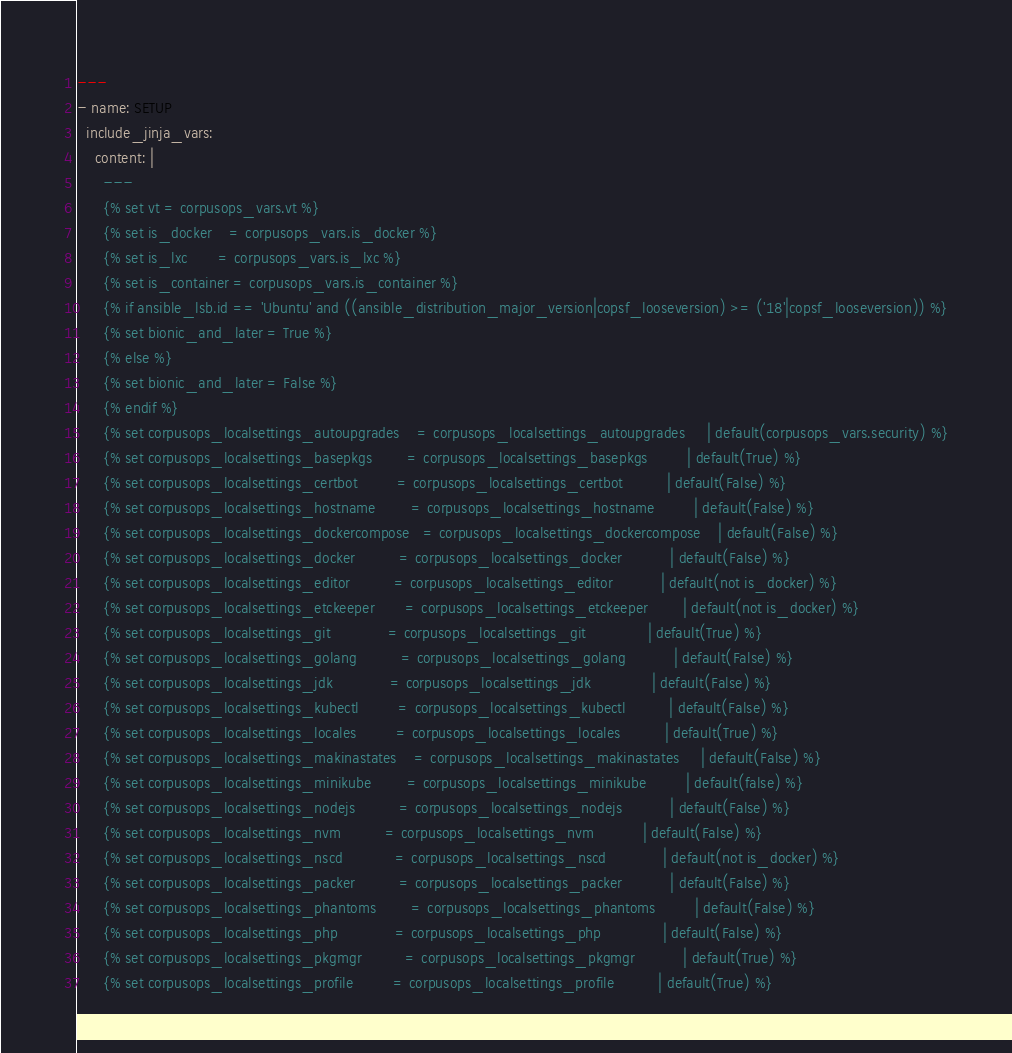Convert code to text. <code><loc_0><loc_0><loc_500><loc_500><_YAML_>---
- name: SETUP
  include_jinja_vars:
    content: |
      ---
      {% set vt = corpusops_vars.vt %}
      {% set is_docker    = corpusops_vars.is_docker %}
      {% set is_lxc       = corpusops_vars.is_lxc %}
      {% set is_container = corpusops_vars.is_container %}
      {% if ansible_lsb.id == 'Ubuntu' and ((ansible_distribution_major_version|copsf_looseversion) >= ('18'|copsf_looseversion)) %}
      {% set bionic_and_later = True %}
      {% else %}
      {% set bionic_and_later = False %}
      {% endif %}
      {% set corpusops_localsettings_autoupgrades    = corpusops_localsettings_autoupgrades     | default(corpusops_vars.security) %}
      {% set corpusops_localsettings_basepkgs        = corpusops_localsettings_basepkgs         | default(True) %}
      {% set corpusops_localsettings_certbot         = corpusops_localsettings_certbot          | default(False) %}
      {% set corpusops_localsettings_hostname        = corpusops_localsettings_hostname         | default(False) %}
      {% set corpusops_localsettings_dockercompose   = corpusops_localsettings_dockercompose    | default(False) %}
      {% set corpusops_localsettings_docker          = corpusops_localsettings_docker           | default(False) %}
      {% set corpusops_localsettings_editor          = corpusops_localsettings_editor           | default(not is_docker) %}
      {% set corpusops_localsettings_etckeeper       = corpusops_localsettings_etckeeper        | default(not is_docker) %}
      {% set corpusops_localsettings_git             = corpusops_localsettings_git              | default(True) %}
      {% set corpusops_localsettings_golang          = corpusops_localsettings_golang           | default(False) %}
      {% set corpusops_localsettings_jdk             = corpusops_localsettings_jdk              | default(False) %}
      {% set corpusops_localsettings_kubectl         = corpusops_localsettings_kubectl          | default(False) %}
      {% set corpusops_localsettings_locales         = corpusops_localsettings_locales          | default(True) %}
      {% set corpusops_localsettings_makinastates    = corpusops_localsettings_makinastates     | default(False) %}
      {% set corpusops_localsettings_minikube        = corpusops_localsettings_minikube         | default(false) %}
      {% set corpusops_localsettings_nodejs          = corpusops_localsettings_nodejs           | default(False) %}
      {% set corpusops_localsettings_nvm          = corpusops_localsettings_nvm           | default(False) %}
      {% set corpusops_localsettings_nscd            = corpusops_localsettings_nscd             | default(not is_docker) %}
      {% set corpusops_localsettings_packer          = corpusops_localsettings_packer           | default(False) %}
      {% set corpusops_localsettings_phantoms        = corpusops_localsettings_phantoms         | default(False) %}
      {% set corpusops_localsettings_php             = corpusops_localsettings_php              | default(False) %}
      {% set corpusops_localsettings_pkgmgr          = corpusops_localsettings_pkgmgr           | default(True) %}
      {% set corpusops_localsettings_profile         = corpusops_localsettings_profile          | default(True) %}</code> 